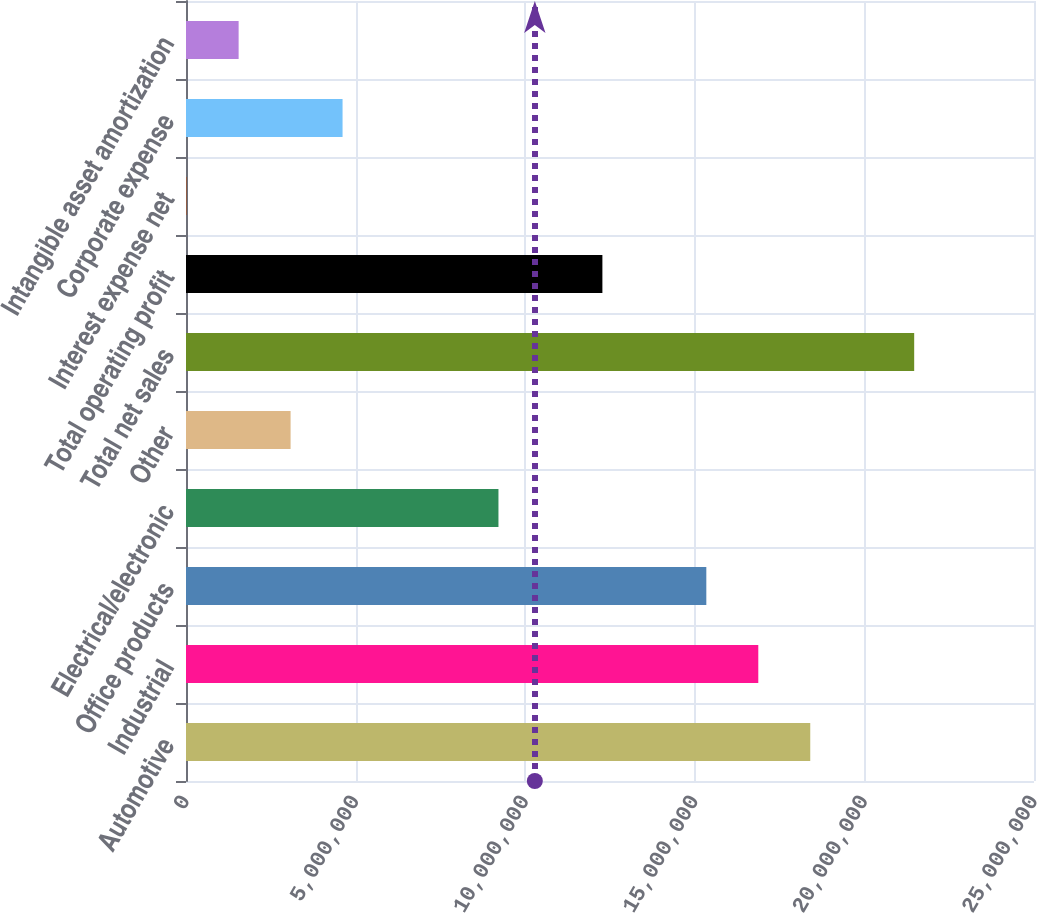Convert chart. <chart><loc_0><loc_0><loc_500><loc_500><bar_chart><fcel>Automotive<fcel>Industrial<fcel>Office products<fcel>Electrical/electronic<fcel>Other<fcel>Total net sales<fcel>Total operating profit<fcel>Interest expense net<fcel>Corporate expense<fcel>Intangible asset amortization<nl><fcel>1.84038e+07<fcel>1.68717e+07<fcel>1.53397e+07<fcel>9.21164e+06<fcel>3.08356e+06<fcel>2.14678e+07<fcel>1.22757e+07<fcel>19525<fcel>4.61558e+06<fcel>1.55154e+06<nl></chart> 